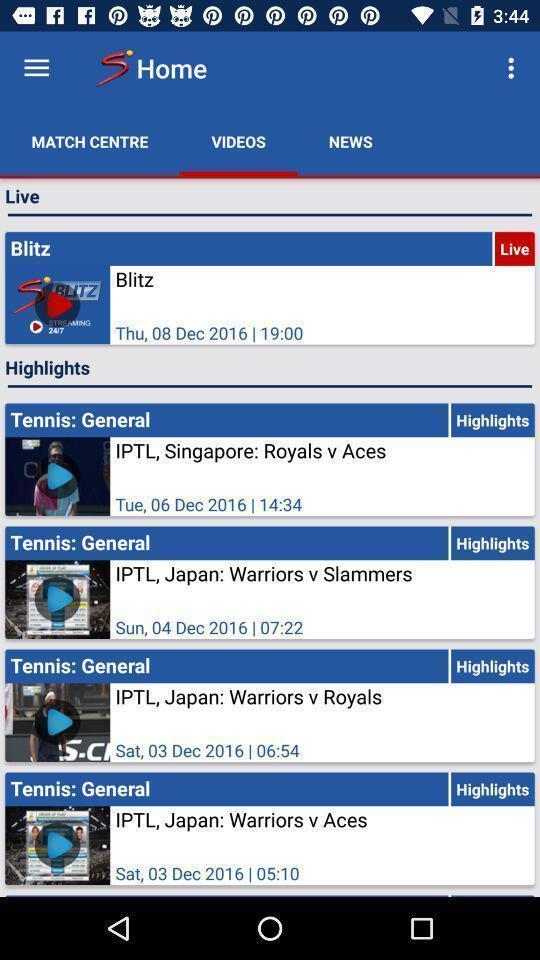Describe this image in words. Page showing information from video app. 